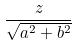<formula> <loc_0><loc_0><loc_500><loc_500>\frac { z } { \sqrt { a ^ { 2 } + b ^ { 2 } } }</formula> 